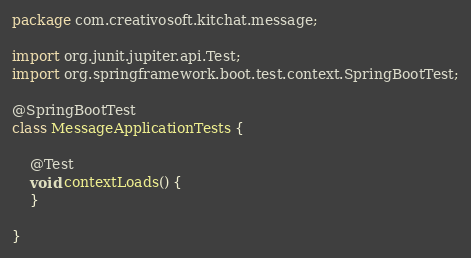Convert code to text. <code><loc_0><loc_0><loc_500><loc_500><_Java_>package com.creativosoft.kitchat.message;

import org.junit.jupiter.api.Test;
import org.springframework.boot.test.context.SpringBootTest;

@SpringBootTest
class MessageApplicationTests {

    @Test
    void contextLoads() {
    }

}
</code> 